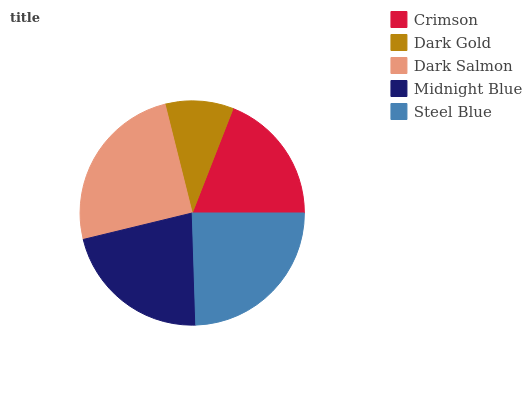Is Dark Gold the minimum?
Answer yes or no. Yes. Is Dark Salmon the maximum?
Answer yes or no. Yes. Is Dark Salmon the minimum?
Answer yes or no. No. Is Dark Gold the maximum?
Answer yes or no. No. Is Dark Salmon greater than Dark Gold?
Answer yes or no. Yes. Is Dark Gold less than Dark Salmon?
Answer yes or no. Yes. Is Dark Gold greater than Dark Salmon?
Answer yes or no. No. Is Dark Salmon less than Dark Gold?
Answer yes or no. No. Is Midnight Blue the high median?
Answer yes or no. Yes. Is Midnight Blue the low median?
Answer yes or no. Yes. Is Steel Blue the high median?
Answer yes or no. No. Is Dark Gold the low median?
Answer yes or no. No. 